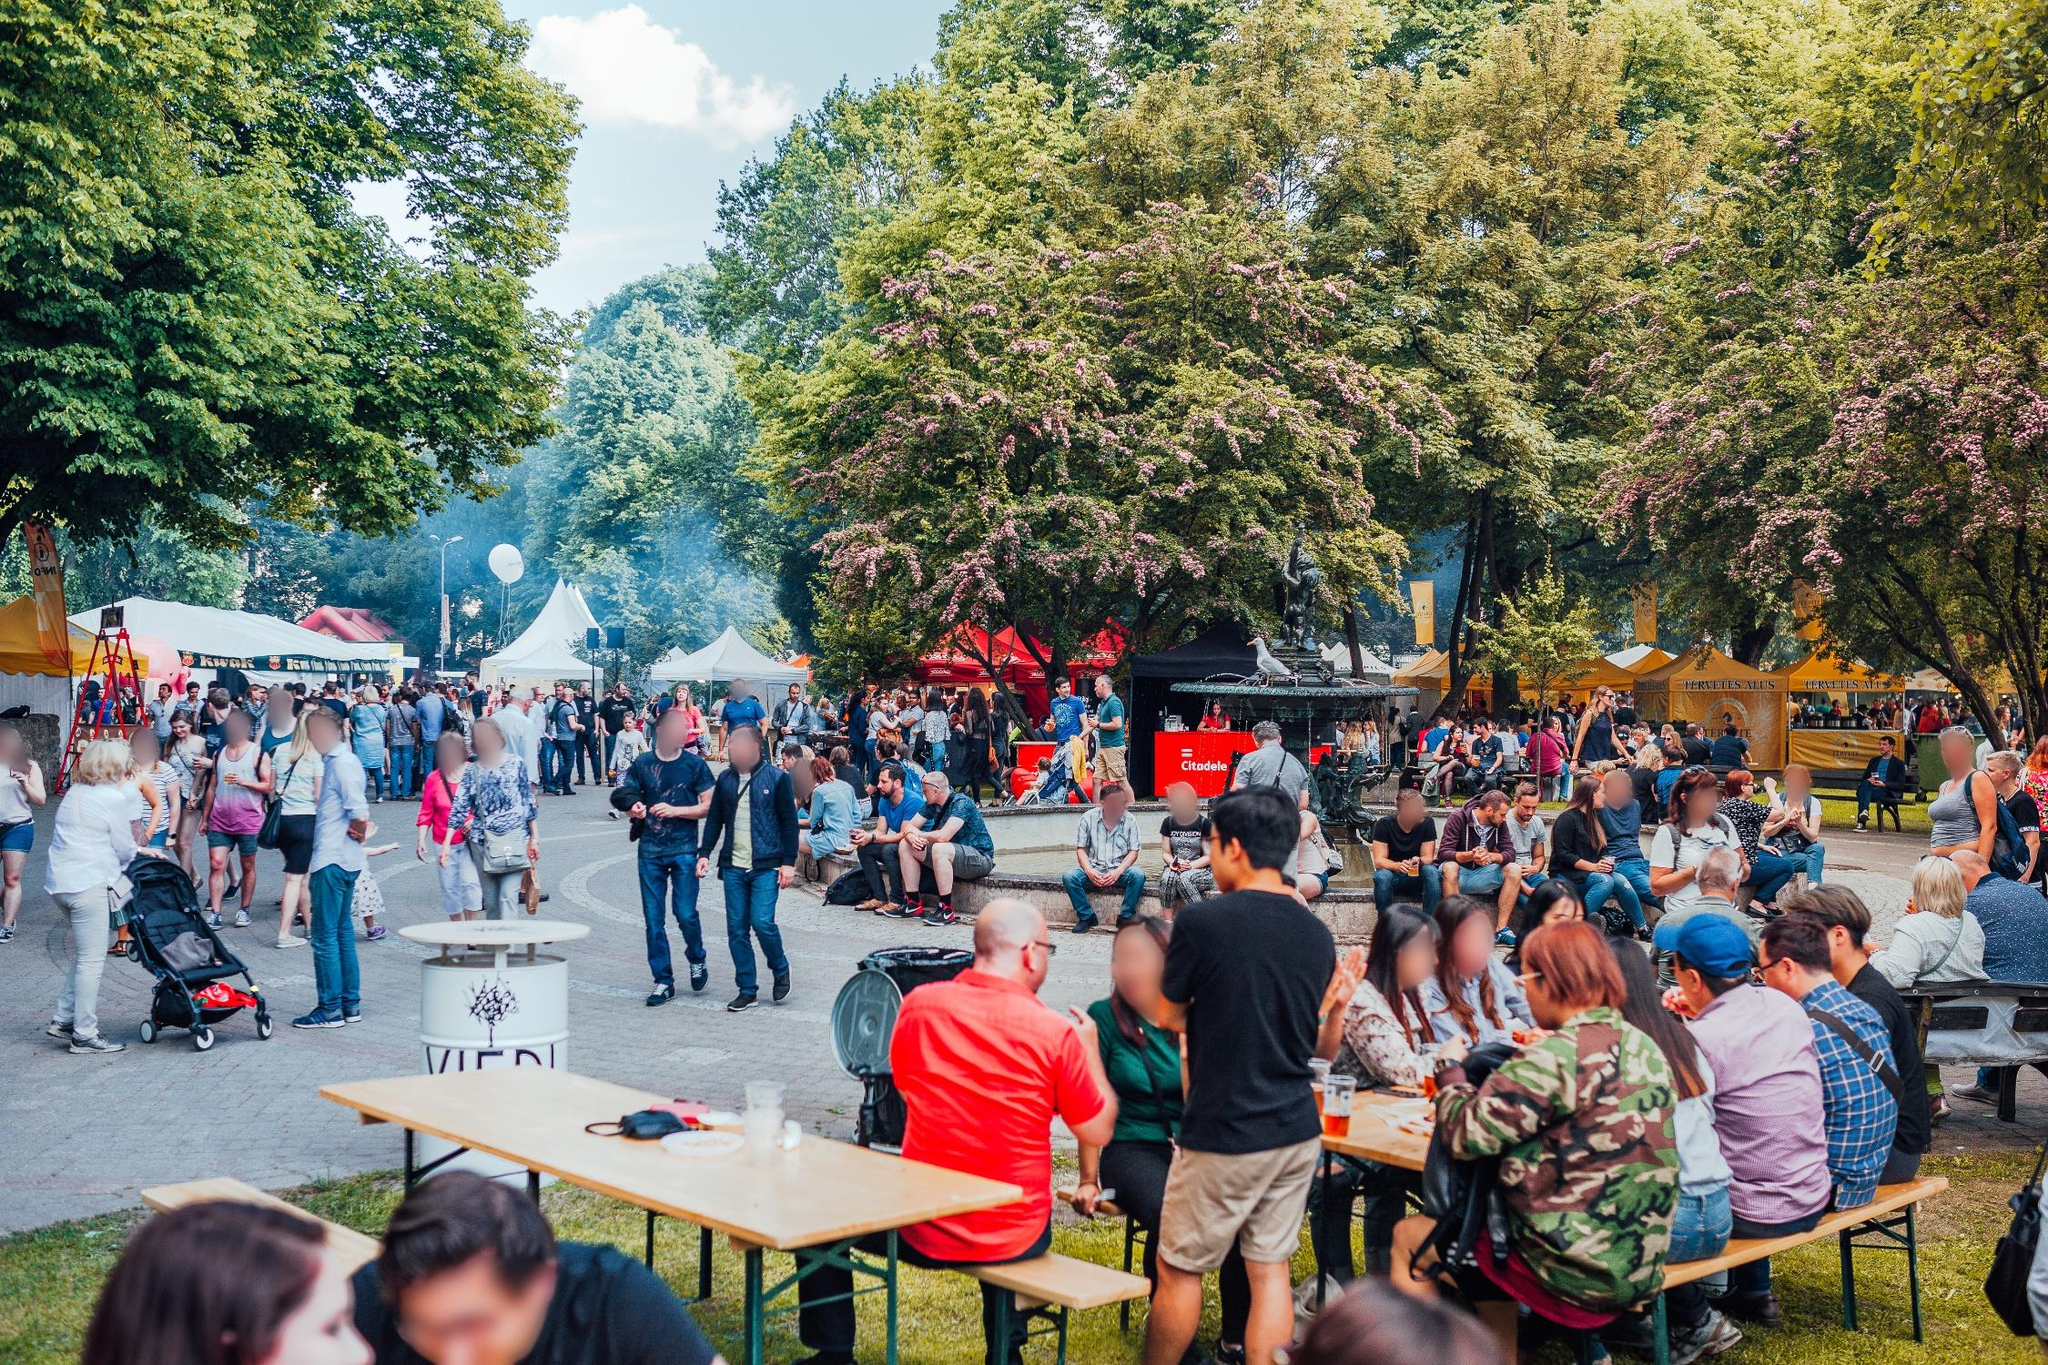Write a detailed description of the given image. The image presents a bustling outdoor festival filled with a diverse crowd of attendees. Captured from an elevated angle, it shows numerous individuals engaged in various activities: walking, eating, and conversing. The park setting adds a natural backdrop with lush green trees and grass, enhancing the festive experience. Multiple tents and food stalls, including a prominent red food truck, offer a variety of culinary delights and merchandise. This festive gathering not only showcases a vibrant community atmosphere but also highlights the joyous interactions among people enjoying a sunny day out. 